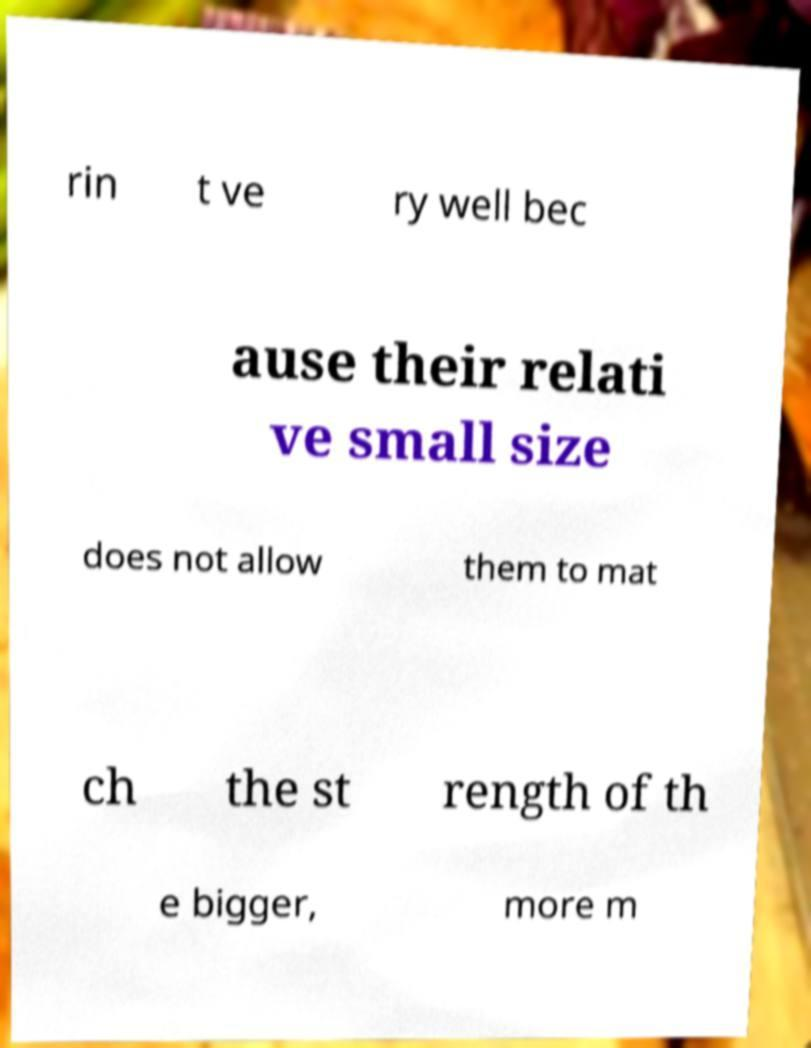Can you read and provide the text displayed in the image?This photo seems to have some interesting text. Can you extract and type it out for me? rin t ve ry well bec ause their relati ve small size does not allow them to mat ch the st rength of th e bigger, more m 